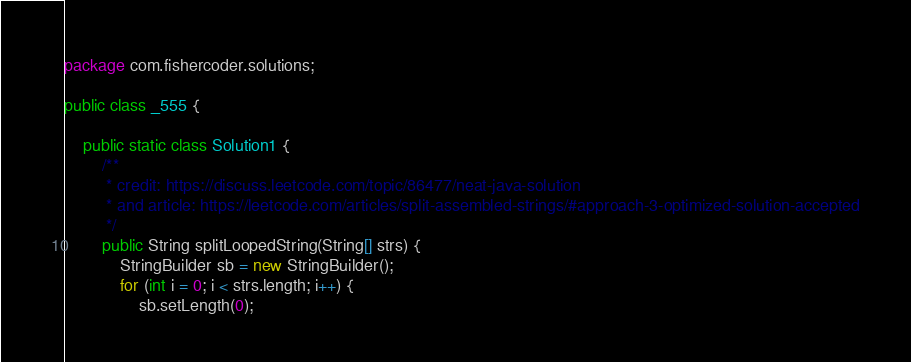Convert code to text. <code><loc_0><loc_0><loc_500><loc_500><_Java_>package com.fishercoder.solutions;

public class _555 {

    public static class Solution1 {
        /**
         * credit: https://discuss.leetcode.com/topic/86477/neat-java-solution
         * and article: https://leetcode.com/articles/split-assembled-strings/#approach-3-optimized-solution-accepted
         */
        public String splitLoopedString(String[] strs) {
            StringBuilder sb = new StringBuilder();
            for (int i = 0; i < strs.length; i++) {
                sb.setLength(0);</code> 